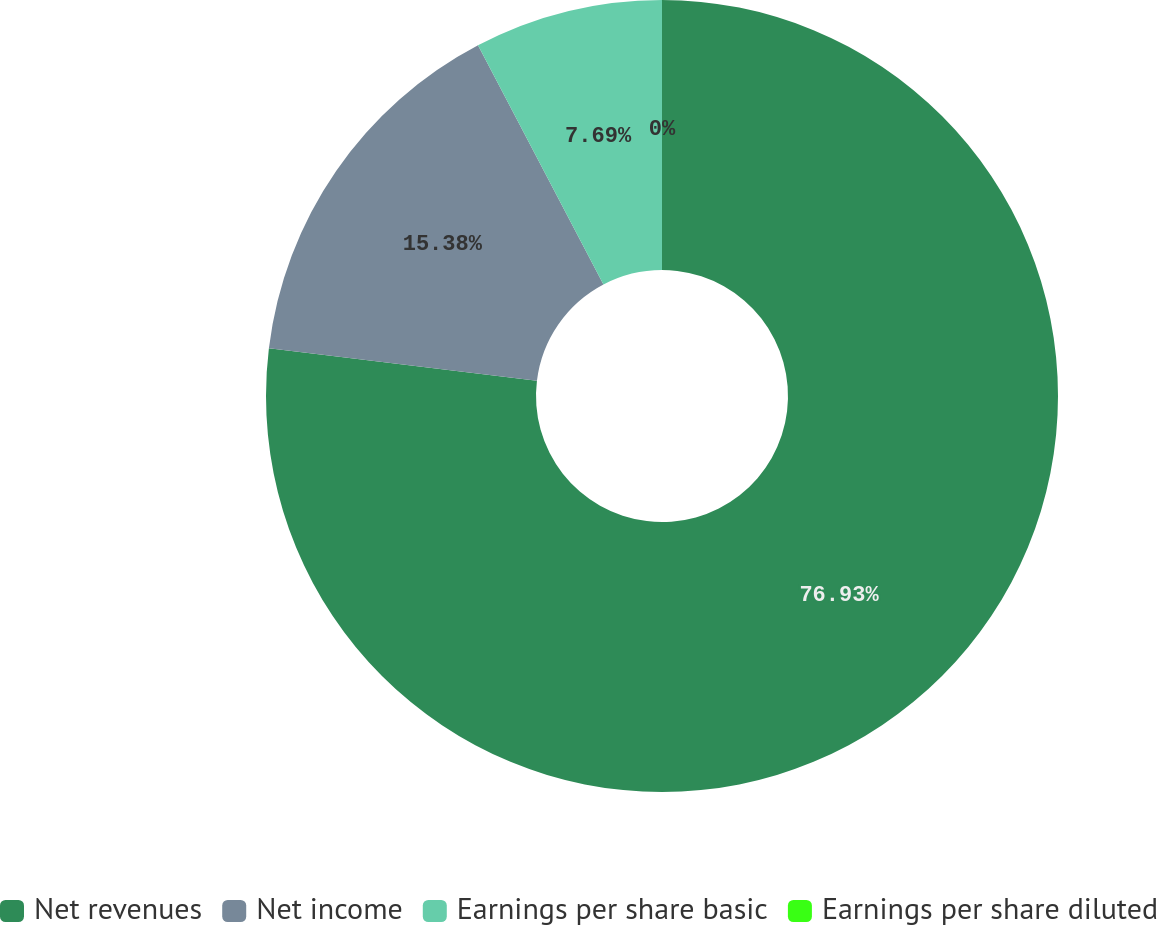Convert chart. <chart><loc_0><loc_0><loc_500><loc_500><pie_chart><fcel>Net revenues<fcel>Net income<fcel>Earnings per share basic<fcel>Earnings per share diluted<nl><fcel>76.92%<fcel>15.38%<fcel>7.69%<fcel>0.0%<nl></chart> 